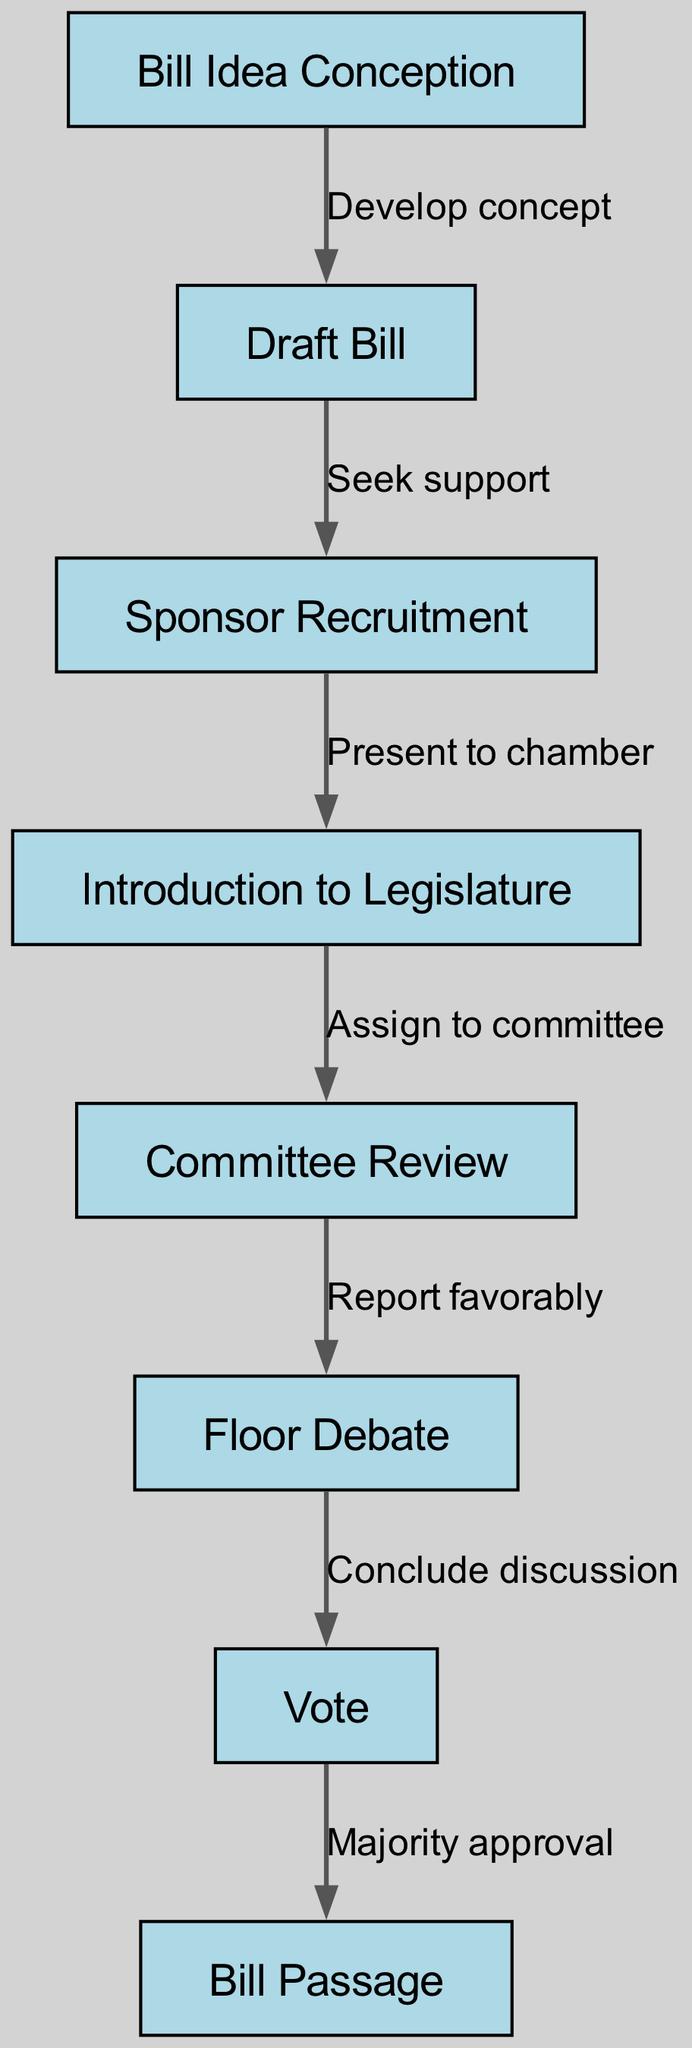What is the first step in the legislative bill proposal process? The first step represented in the diagram is "Bill Idea Conception," which is the initial stage where the idea for a bill is formed.
Answer: Bill Idea Conception How many nodes are present in the diagram? The diagram contains a total of eight nodes, which represent various stages in the legislative bill proposal process.
Answer: 8 What follows the "Sponsor Recruitment" in the process? After "Sponsor Recruitment," the next step in the process as shown in the diagram is "Introduction to Legislature." This indicates that once a sponsor is recruited, the bill is introduced to the legislative body.
Answer: Introduction to Legislature What is the relationship between "Committee Review" and "Vote"? The relationship depicted in the diagram shows that after the "Committee Review" stage, which reports favorably, the process moves to "Floor Debate" before a "Vote" is held. This indicates a sequential flow from committee review to voting.
Answer: Conclude discussion How many steps are there from “Bill Idea Conception” to “Bill Passage”? To determine the number of steps from "Bill Idea Conception" to "Bill Passage," we trace the flow through the diagram: 1. Bill Idea Conception 2. Draft Bill 3. Sponsor Recruitment 4. Introduction to Legislature 5. Committee Review 6. Floor Debate 7. Vote 8. Bill Passage, which totals eight distinct steps.
Answer: 8 What stage comes after “Floor Debate”? The stage that comes immediately after "Floor Debate" is "Vote," indicating that discussion concludes before the legislative vote takes place.
Answer: Vote Which edge connects "Draft Bill" and "Sponsor Recruitment"? The edge connecting "Draft Bill" and "Sponsor Recruitment" is labeled "Seek support," indicating that after drafting the bill, the next step is to seek support for the proposal.
Answer: Seek support What is the final outcome in the legislative process as per the diagram? The final outcome in the legislative process according to the diagram is "Bill Passage," which occurs after receiving majority approval during the vote.
Answer: Bill Passage 